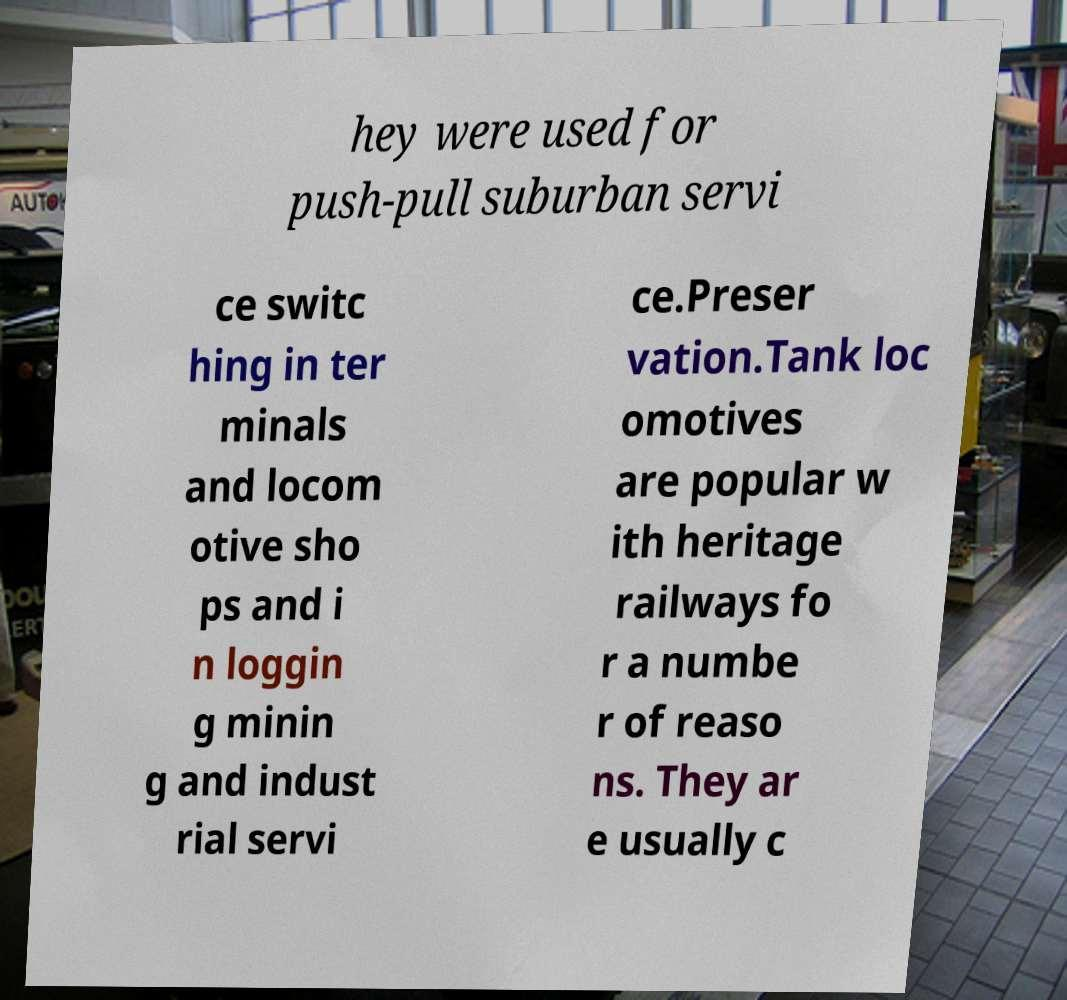What messages or text are displayed in this image? I need them in a readable, typed format. hey were used for push-pull suburban servi ce switc hing in ter minals and locom otive sho ps and i n loggin g minin g and indust rial servi ce.Preser vation.Tank loc omotives are popular w ith heritage railways fo r a numbe r of reaso ns. They ar e usually c 